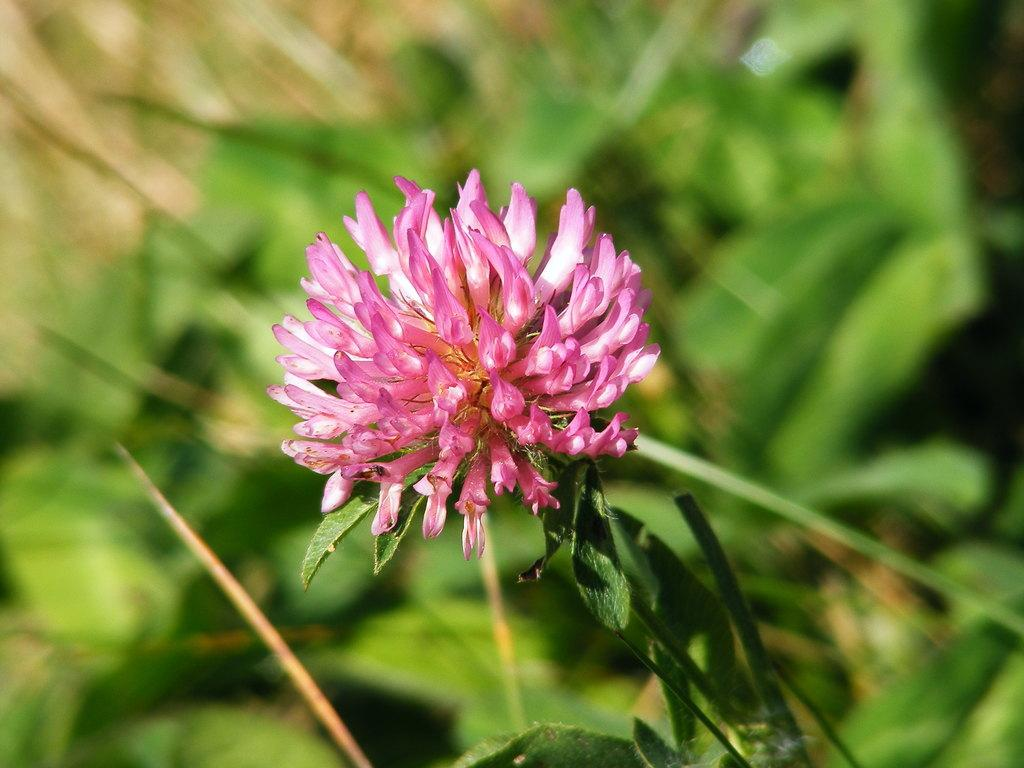What is the main subject of the image? There is a plant with a flower in the image. Are there any other plants visible in the image? Yes, there are other plants in the background of the image. How would you describe the background of the image? The background of the image is blurred. Can you see any worms crawling on the flower in the image? There are no worms visible in the image. What type of cherry is being used as a decoration on the plant in the image? There is no cherry present in the image. 